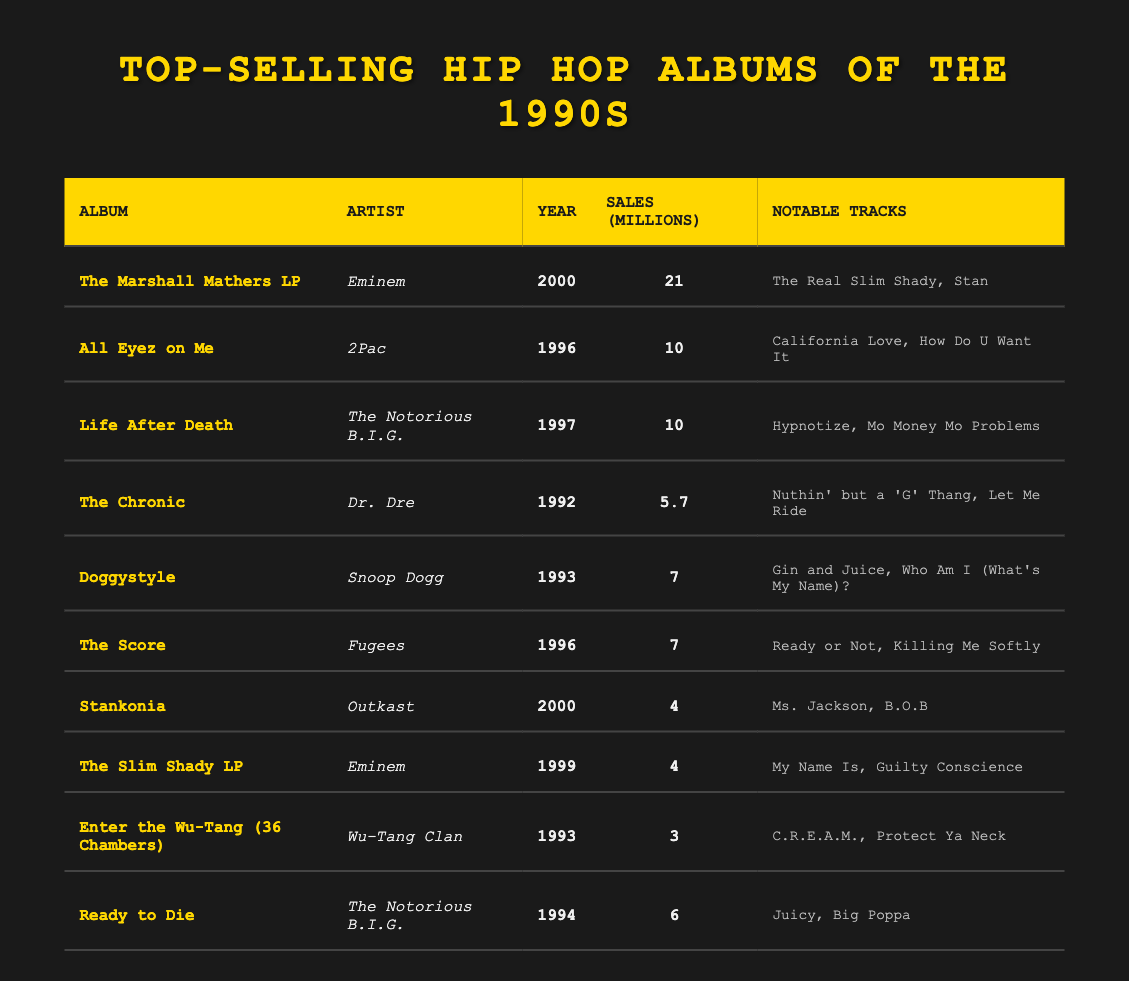What is the top-selling hip hop album of the 1990s? The top-selling album is "The Marshall Mathers LP" by Eminem with sales of 21 million copies.
Answer: The Marshall Mathers LP Which artist has the highest number of album sales in this table? Eminem has the highest number of album sales with "The Marshall Mathers LP" at 21 million and "The Slim Shady LP" at 4 million, totaling 25 million.
Answer: Eminem How many albums had sales of 7 million or more? There are 4 albums with sales of 7 million or more: "All Eyez on Me" (10), "Life After Death" (10), "Doggystyle" (7), and "The Score" (7).
Answer: 4 What is the total sales of albums by The Notorious B.I.G.? The total sales of albums by The Notorious B.I.G. are 16 million (10 from "Life After Death" and 6 from "Ready to Die").
Answer: 16 million Is "Enter the Wu-Tang (36 Chambers)" the first album listed? No, "Enter the Wu-Tang (36 Chambers)" is not the first album; it is listed 9th in the table.
Answer: No Which year had the most album releases from this table? The year 1996 had three albums: "All Eyez on Me," "Life After Death," and "The Score," making it the year with the most releases in the table.
Answer: 1996 What is the average sales of albums listed from the year 2000? There are two albums from 2000: "The Marshall Mathers LP" (21 million) and "Stankonia" (4 million). The average is (21 + 4)/2 = 12.5 million.
Answer: 12.5 million Did Dr. Dre's album have more sales than Snoop Dogg's album? Yes, Dr. Dre's "The Chronic" sold 5.7 million, which is more than Snoop Dogg's "Doggystyle" at 7 million.
Answer: No How many notable tracks are mentioned for the album "Stankonia"? The album "Stankonia" has two notable tracks listed: "Ms. Jackson" and "B.O.B".
Answer: 2 